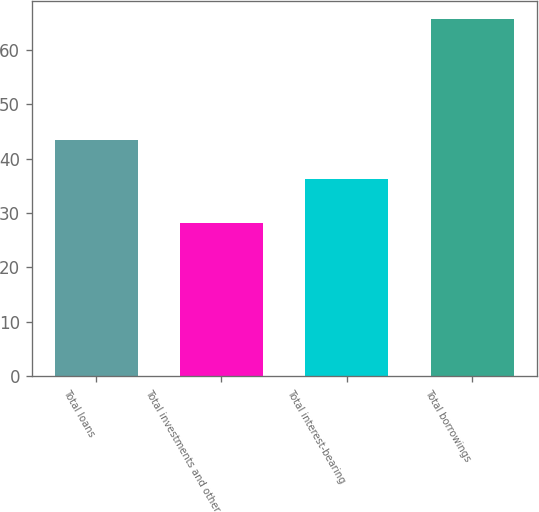<chart> <loc_0><loc_0><loc_500><loc_500><bar_chart><fcel>Total loans<fcel>Total investments and other<fcel>Total interest-bearing<fcel>Total borrowings<nl><fcel>43.5<fcel>28.2<fcel>36.3<fcel>65.6<nl></chart> 